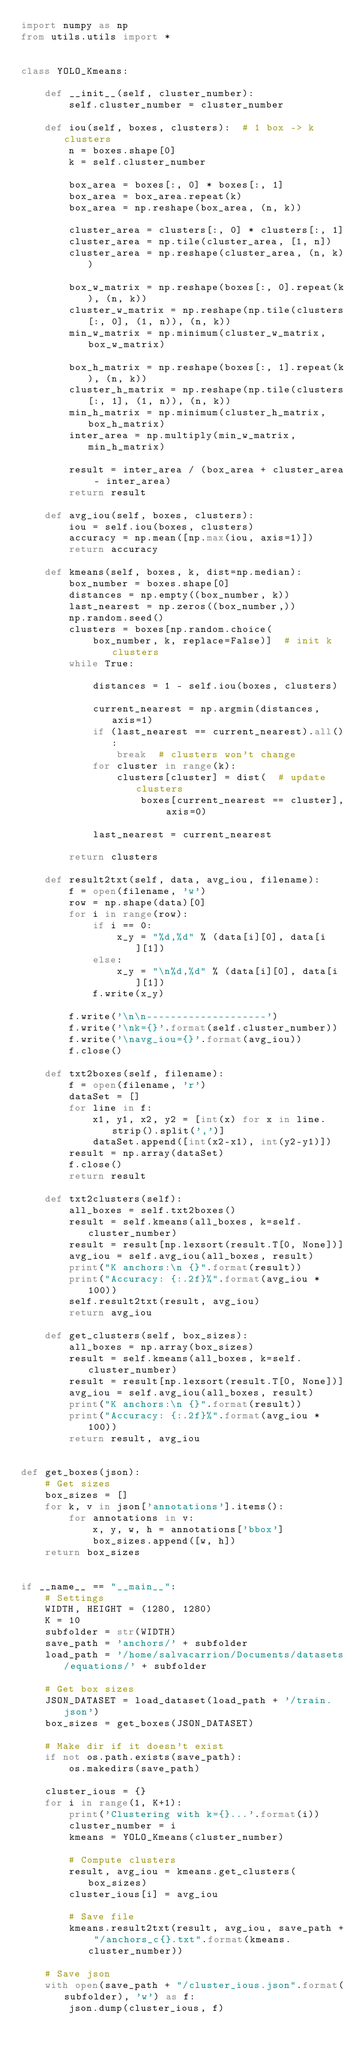Convert code to text. <code><loc_0><loc_0><loc_500><loc_500><_Python_>import numpy as np
from utils.utils import *


class YOLO_Kmeans:

    def __init__(self, cluster_number):
        self.cluster_number = cluster_number

    def iou(self, boxes, clusters):  # 1 box -> k clusters
        n = boxes.shape[0]
        k = self.cluster_number

        box_area = boxes[:, 0] * boxes[:, 1]
        box_area = box_area.repeat(k)
        box_area = np.reshape(box_area, (n, k))

        cluster_area = clusters[:, 0] * clusters[:, 1]
        cluster_area = np.tile(cluster_area, [1, n])
        cluster_area = np.reshape(cluster_area, (n, k))

        box_w_matrix = np.reshape(boxes[:, 0].repeat(k), (n, k))
        cluster_w_matrix = np.reshape(np.tile(clusters[:, 0], (1, n)), (n, k))
        min_w_matrix = np.minimum(cluster_w_matrix, box_w_matrix)

        box_h_matrix = np.reshape(boxes[:, 1].repeat(k), (n, k))
        cluster_h_matrix = np.reshape(np.tile(clusters[:, 1], (1, n)), (n, k))
        min_h_matrix = np.minimum(cluster_h_matrix, box_h_matrix)
        inter_area = np.multiply(min_w_matrix, min_h_matrix)

        result = inter_area / (box_area + cluster_area - inter_area)
        return result

    def avg_iou(self, boxes, clusters):
        iou = self.iou(boxes, clusters)
        accuracy = np.mean([np.max(iou, axis=1)])
        return accuracy

    def kmeans(self, boxes, k, dist=np.median):
        box_number = boxes.shape[0]
        distances = np.empty((box_number, k))
        last_nearest = np.zeros((box_number,))
        np.random.seed()
        clusters = boxes[np.random.choice(
            box_number, k, replace=False)]  # init k clusters
        while True:

            distances = 1 - self.iou(boxes, clusters)

            current_nearest = np.argmin(distances, axis=1)
            if (last_nearest == current_nearest).all():
                break  # clusters won't change
            for cluster in range(k):
                clusters[cluster] = dist(  # update clusters
                    boxes[current_nearest == cluster], axis=0)

            last_nearest = current_nearest

        return clusters

    def result2txt(self, data, avg_iou, filename):
        f = open(filename, 'w')
        row = np.shape(data)[0]
        for i in range(row):
            if i == 0:
                x_y = "%d,%d" % (data[i][0], data[i][1])
            else:
                x_y = "\n%d,%d" % (data[i][0], data[i][1])
            f.write(x_y)

        f.write('\n\n--------------------')
        f.write('\nk={}'.format(self.cluster_number))
        f.write('\navg_iou={}'.format(avg_iou))
        f.close()

    def txt2boxes(self, filename):
        f = open(filename, 'r')
        dataSet = []
        for line in f:
            x1, y1, x2, y2 = [int(x) for x in line.strip().split(',')]
            dataSet.append([int(x2-x1), int(y2-y1)])
        result = np.array(dataSet)
        f.close()
        return result

    def txt2clusters(self):
        all_boxes = self.txt2boxes()
        result = self.kmeans(all_boxes, k=self.cluster_number)
        result = result[np.lexsort(result.T[0, None])]
        avg_iou = self.avg_iou(all_boxes, result)
        print("K anchors:\n {}".format(result))
        print("Accuracy: {:.2f}%".format(avg_iou * 100))
        self.result2txt(result, avg_iou)
        return avg_iou

    def get_clusters(self, box_sizes):
        all_boxes = np.array(box_sizes)
        result = self.kmeans(all_boxes, k=self.cluster_number)
        result = result[np.lexsort(result.T[0, None])]
        avg_iou = self.avg_iou(all_boxes, result)
        print("K anchors:\n {}".format(result))
        print("Accuracy: {:.2f}%".format(avg_iou * 100))
        return result, avg_iou


def get_boxes(json):
    # Get sizes
    box_sizes = []
    for k, v in json['annotations'].items():
        for annotations in v:
            x, y, w, h = annotations['bbox']
            box_sizes.append([w, h])
    return box_sizes


if __name__ == "__main__":
    # Settings
    WIDTH, HEIGHT = (1280, 1280)
    K = 10
    subfolder = str(WIDTH)
    save_path = 'anchors/' + subfolder
    load_path = '/home/salvacarrion/Documents/datasets/equations/' + subfolder

    # Get box sizes
    JSON_DATASET = load_dataset(load_path + '/train.json')
    box_sizes = get_boxes(JSON_DATASET)

    # Make dir if it doesn't exist
    if not os.path.exists(save_path):
        os.makedirs(save_path)

    cluster_ious = {}
    for i in range(1, K+1):
        print('Clustering with k={}...'.format(i))
        cluster_number = i
        kmeans = YOLO_Kmeans(cluster_number)

        # Compute clusters
        result, avg_iou = kmeans.get_clusters(box_sizes)
        cluster_ious[i] = avg_iou

        # Save file
        kmeans.result2txt(result, avg_iou, save_path + "/anchors_c{}.txt".format(kmeans.cluster_number))

    # Save json
    with open(save_path + "/cluster_ious.json".format(subfolder), 'w') as f:
        json.dump(cluster_ious, f)


</code> 